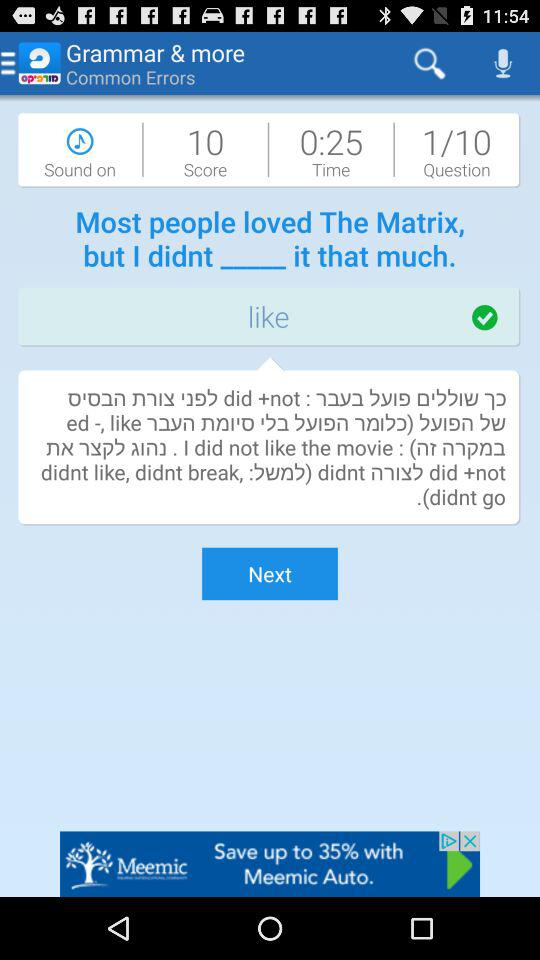How many questions are there? There are 10 questions. 